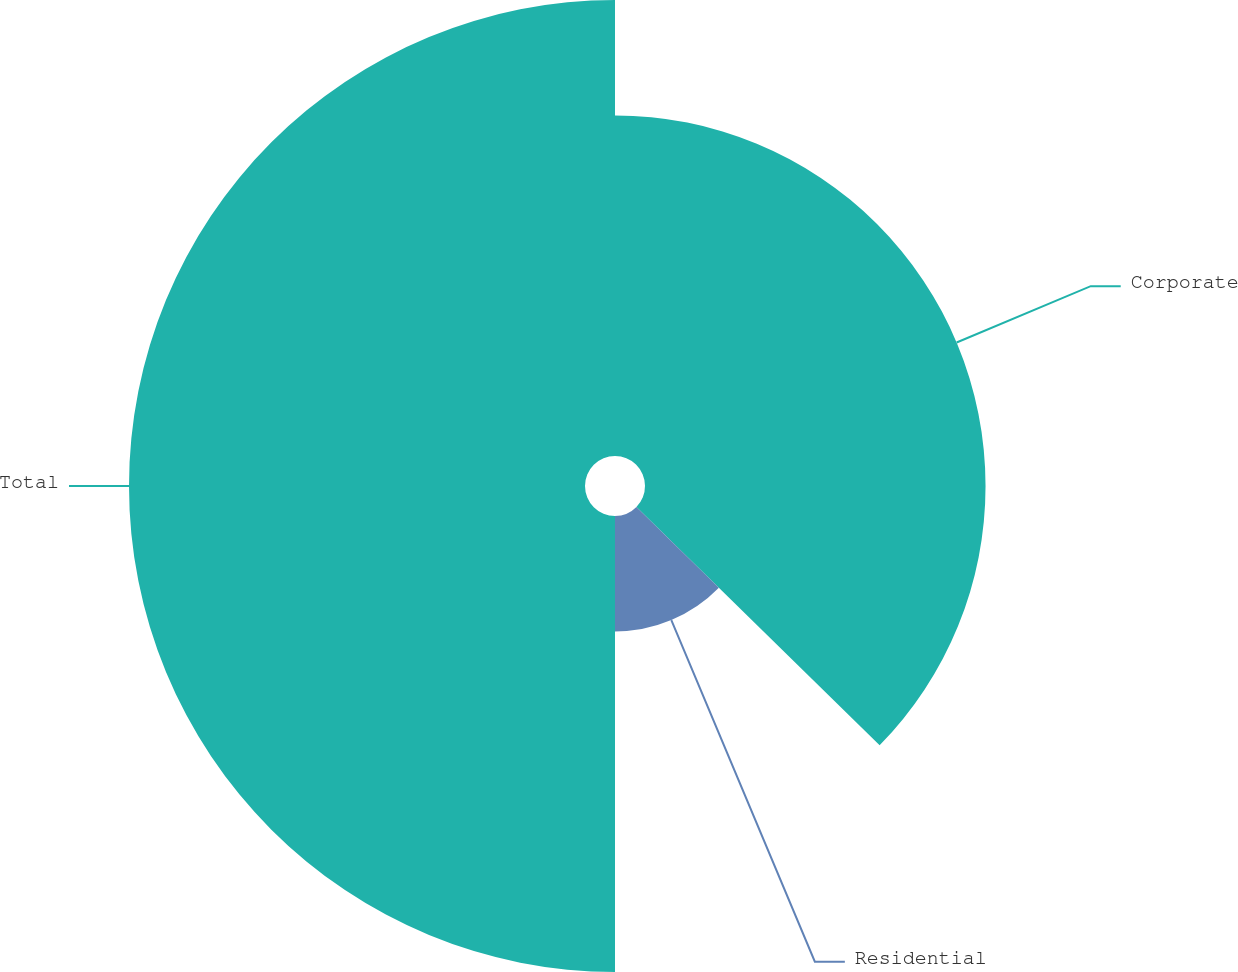Convert chart to OTSL. <chart><loc_0><loc_0><loc_500><loc_500><pie_chart><fcel>Corporate<fcel>Residential<fcel>Total<nl><fcel>37.34%<fcel>12.66%<fcel>50.0%<nl></chart> 